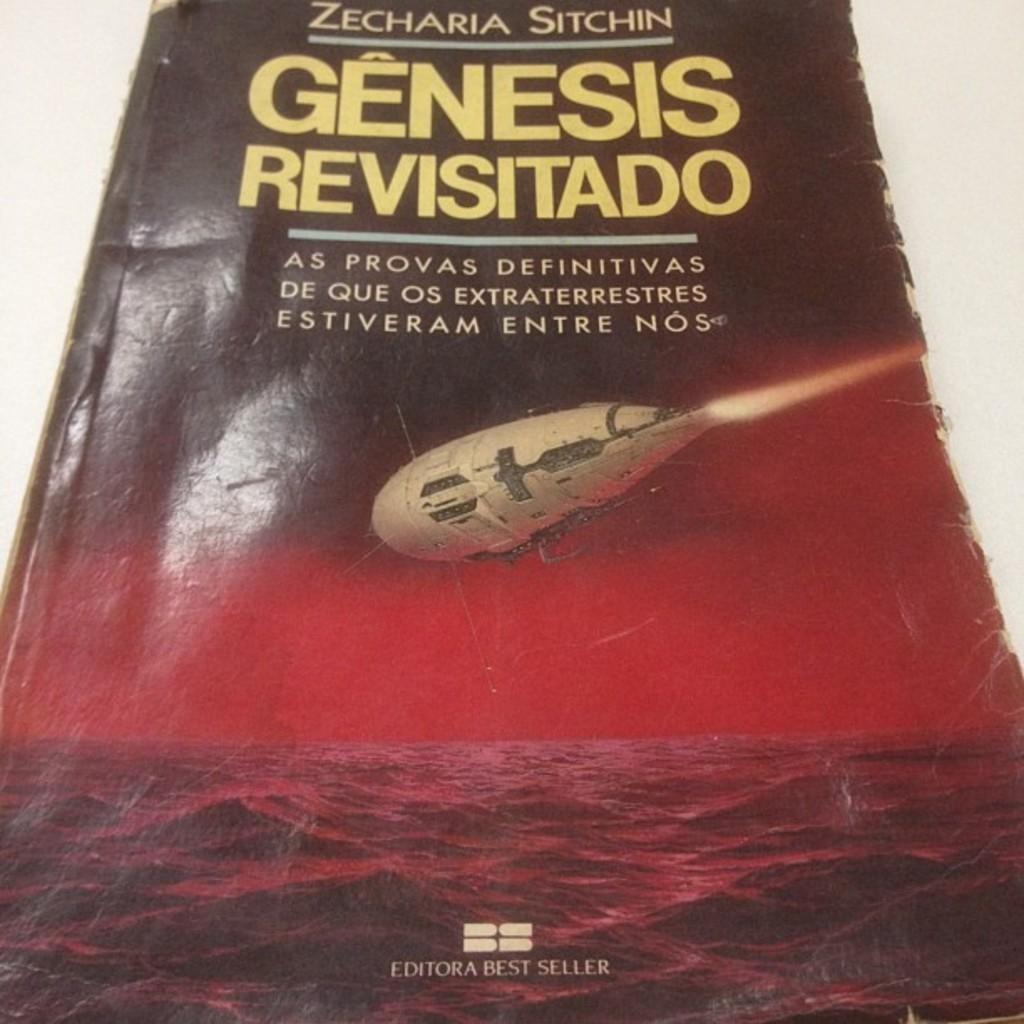<image>
Render a clear and concise summary of the photo. a book cover of a book called genesis revisitado by Zecharia Sitchin 